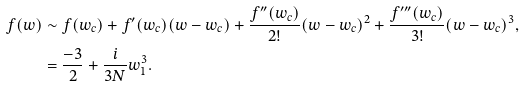<formula> <loc_0><loc_0><loc_500><loc_500>f ( w ) & \sim f ( w _ { c } ) + f ^ { \prime } ( w _ { c } ) ( w - w _ { c } ) + \frac { f ^ { \prime \prime } ( w _ { c } ) } { 2 ! } ( w - w _ { c } ) ^ { 2 } + \frac { f ^ { \prime \prime \prime } ( w _ { c } ) } { 3 ! } ( w - w _ { c } ) ^ { 3 } , \\ & = \frac { - 3 } { 2 } + \frac { i } { 3 N } w _ { 1 } ^ { 3 } .</formula> 